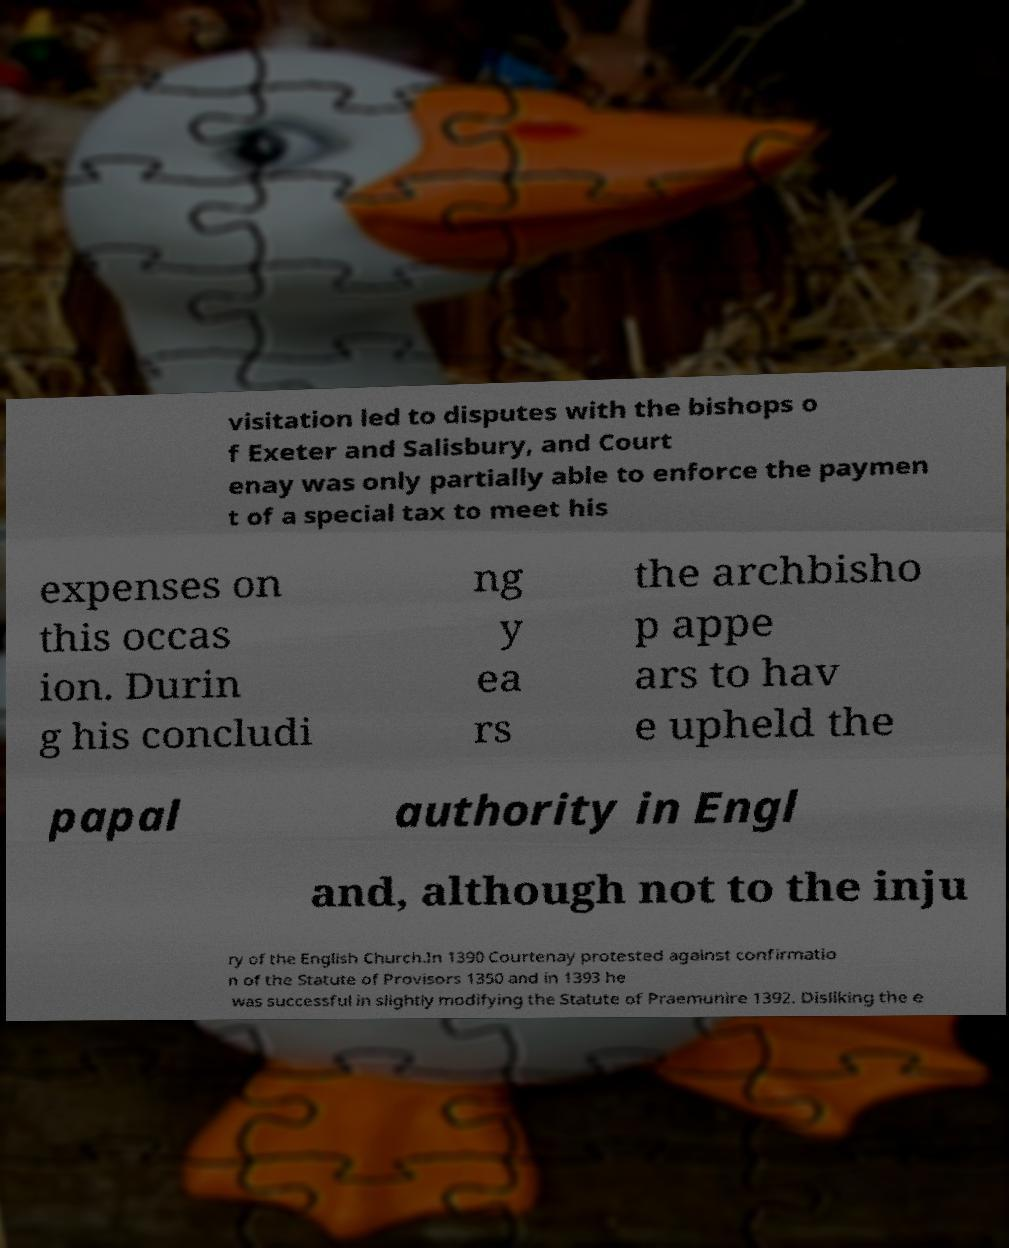Can you accurately transcribe the text from the provided image for me? visitation led to disputes with the bishops o f Exeter and Salisbury, and Court enay was only partially able to enforce the paymen t of a special tax to meet his expenses on this occas ion. Durin g his concludi ng y ea rs the archbisho p appe ars to hav e upheld the papal authority in Engl and, although not to the inju ry of the English Church.In 1390 Courtenay protested against confirmatio n of the Statute of Provisors 1350 and in 1393 he was successful in slightly modifying the Statute of Praemunire 1392. Disliking the e 